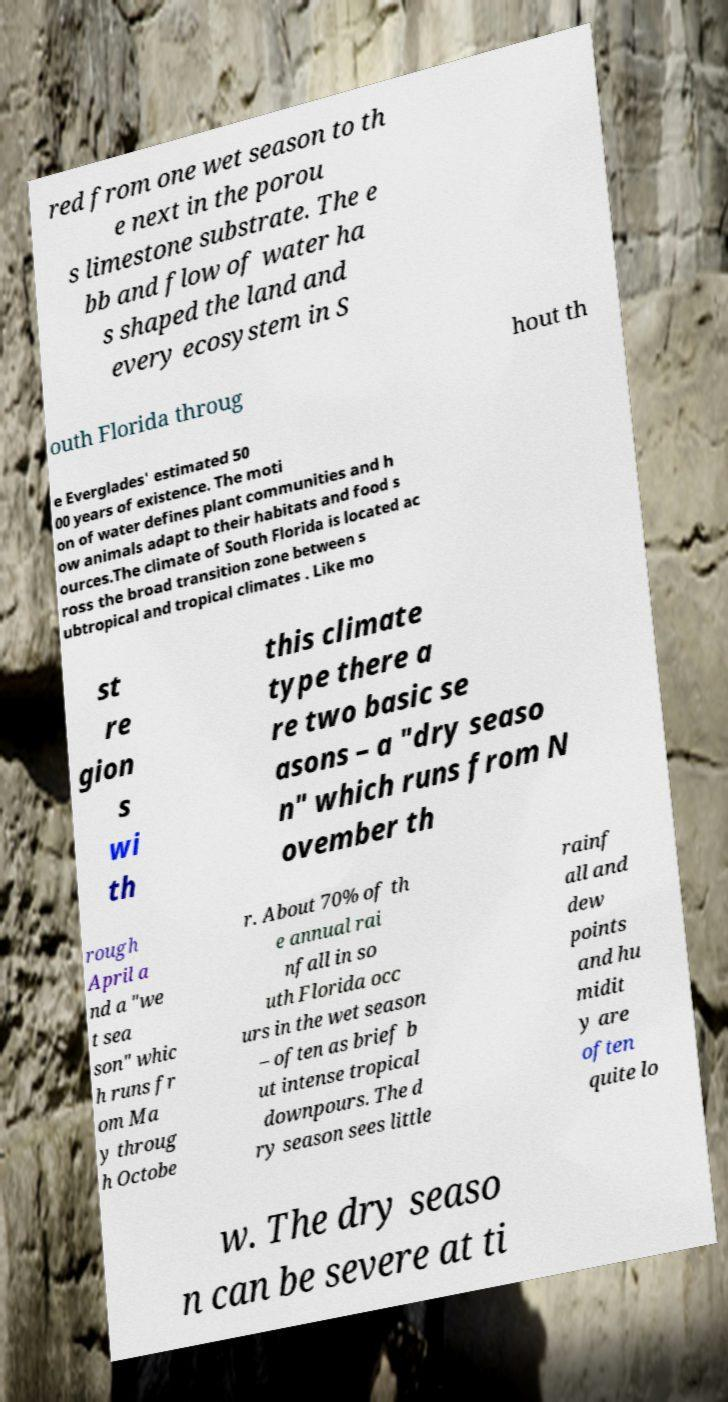There's text embedded in this image that I need extracted. Can you transcribe it verbatim? red from one wet season to th e next in the porou s limestone substrate. The e bb and flow of water ha s shaped the land and every ecosystem in S outh Florida throug hout th e Everglades' estimated 50 00 years of existence. The moti on of water defines plant communities and h ow animals adapt to their habitats and food s ources.The climate of South Florida is located ac ross the broad transition zone between s ubtropical and tropical climates . Like mo st re gion s wi th this climate type there a re two basic se asons – a "dry seaso n" which runs from N ovember th rough April a nd a "we t sea son" whic h runs fr om Ma y throug h Octobe r. About 70% of th e annual rai nfall in so uth Florida occ urs in the wet season – often as brief b ut intense tropical downpours. The d ry season sees little rainf all and dew points and hu midit y are often quite lo w. The dry seaso n can be severe at ti 